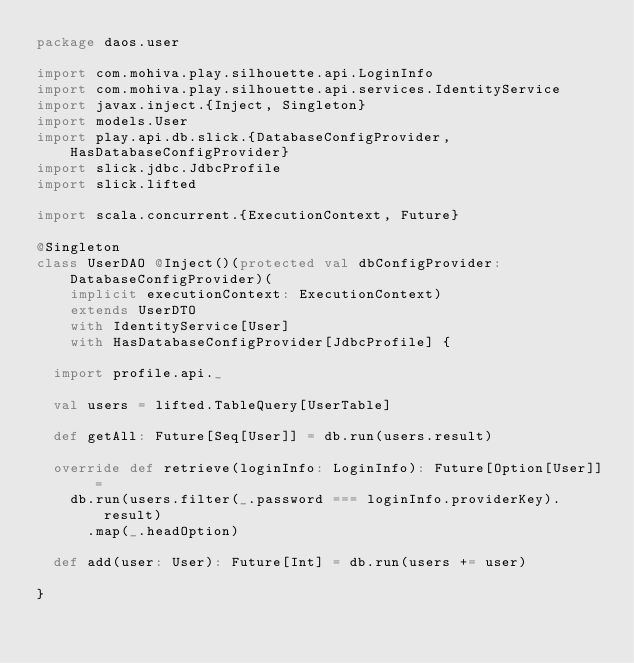<code> <loc_0><loc_0><loc_500><loc_500><_Scala_>package daos.user

import com.mohiva.play.silhouette.api.LoginInfo
import com.mohiva.play.silhouette.api.services.IdentityService
import javax.inject.{Inject, Singleton}
import models.User
import play.api.db.slick.{DatabaseConfigProvider, HasDatabaseConfigProvider}
import slick.jdbc.JdbcProfile
import slick.lifted

import scala.concurrent.{ExecutionContext, Future}

@Singleton
class UserDAO @Inject()(protected val dbConfigProvider: DatabaseConfigProvider)(
    implicit executionContext: ExecutionContext)
    extends UserDTO
    with IdentityService[User]
    with HasDatabaseConfigProvider[JdbcProfile] {

  import profile.api._

  val users = lifted.TableQuery[UserTable]

  def getAll: Future[Seq[User]] = db.run(users.result)

  override def retrieve(loginInfo: LoginInfo): Future[Option[User]] =
    db.run(users.filter(_.password === loginInfo.providerKey).result)
      .map(_.headOption)

  def add(user: User): Future[Int] = db.run(users += user)

}
</code> 